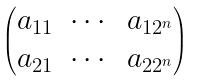Convert formula to latex. <formula><loc_0><loc_0><loc_500><loc_500>\begin{pmatrix} a _ { 1 1 } & \cdots & a _ { 1 2 ^ { n } } \\ a _ { 2 1 } & \cdots & a _ { 2 2 ^ { n } } \end{pmatrix}</formula> 